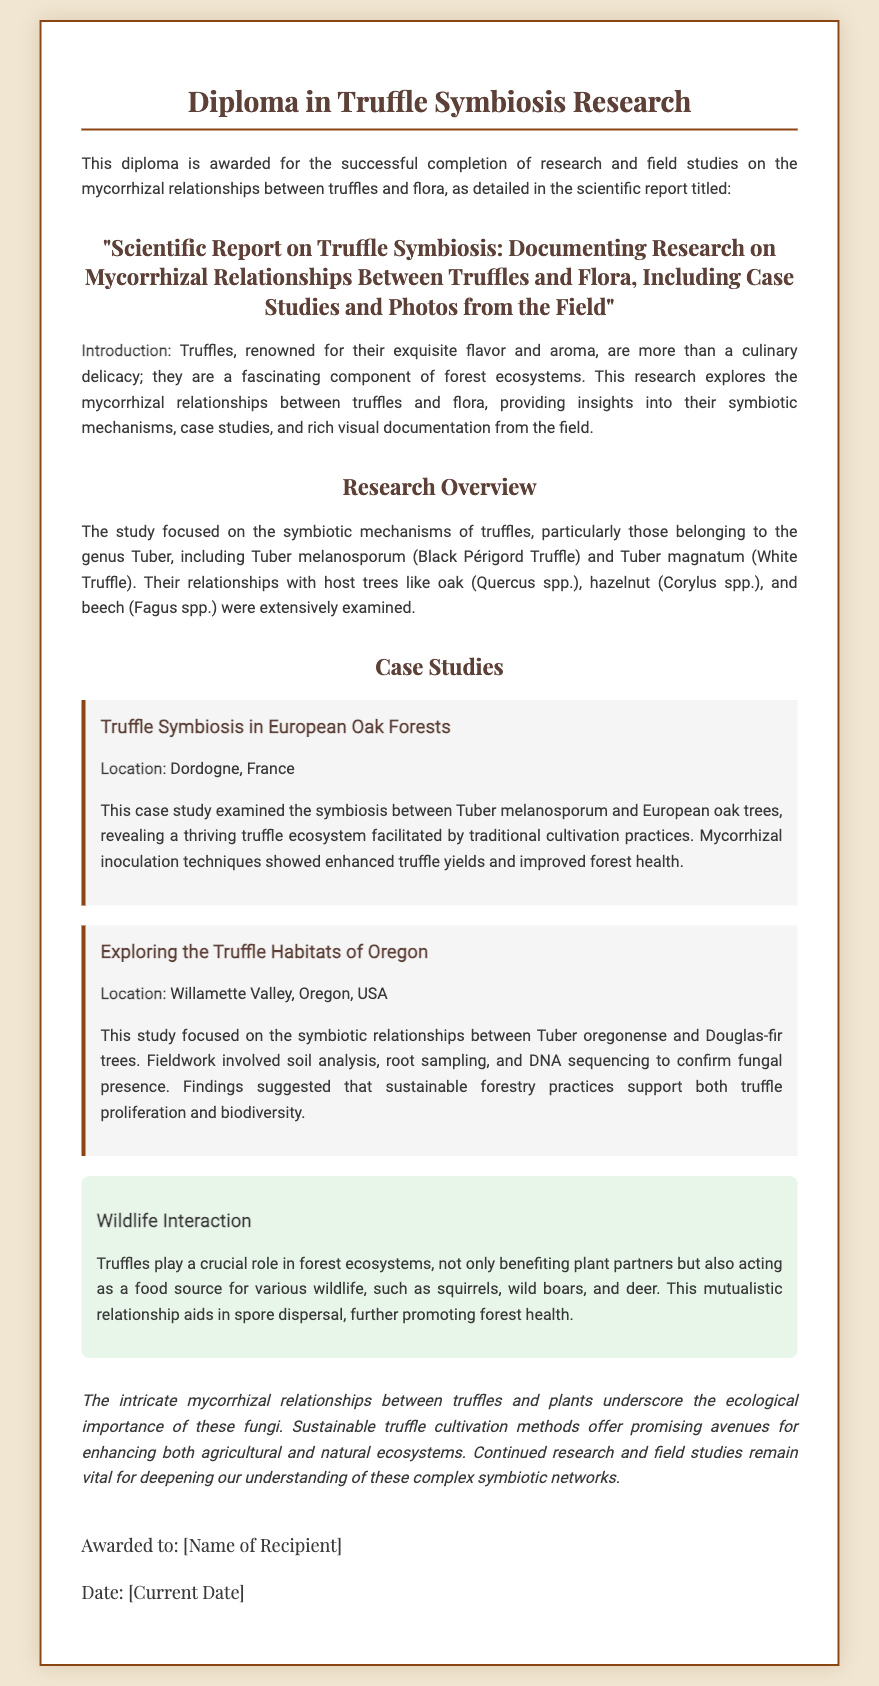What is the title of the scientific report? The title of the scientific report is provided prominently in the diploma section, detailing the research topic.
Answer: "Scientific Report on Truffle Symbiosis: Documenting Research on Mycorrhizal Relationships Between Truffles and Flora, Including Case Studies and Photos from the Field" Which genus of truffles was primarily studied? The diploma mentions the focus on truffles particularly belonging to one genus, highlighting its significance in the research.
Answer: Tuber What is the location of the first case study? The first case study specifies a geographic area where the research was conducted, crucial for understanding the context of the study.
Answer: Dordogne, France What type of trees were studied in relation to Tuber oregonense? The research overview includes specific host plants that have symbiotic relationships with Tuber oregonense, essential for the study's findings.
Answer: Douglas-fir trees What role do truffles play in forest ecosystems according to the document? The document discusses the ecological role of truffles, emphasizing their importance beyond just a food source.
Answer: Food source for wildlife What does the conclusion say about sustainable truffle cultivation? The conclusion section provides a summary insight on sustainable practices and their potential positive impact, key for future recommendations.
Answer: Promising avenues for enhancing both agricultural and natural ecosystems How many case studies are included in the report? The document outlines sections devoted to case studies, indicating the depth of research covered in the report.
Answer: Two What are the names of the two types of truffles highlighted in the research? The research overview lists two specific truffles, providing critical information on the focus species for the study.
Answer: Tuber melanosporum and Tuber magnatum 